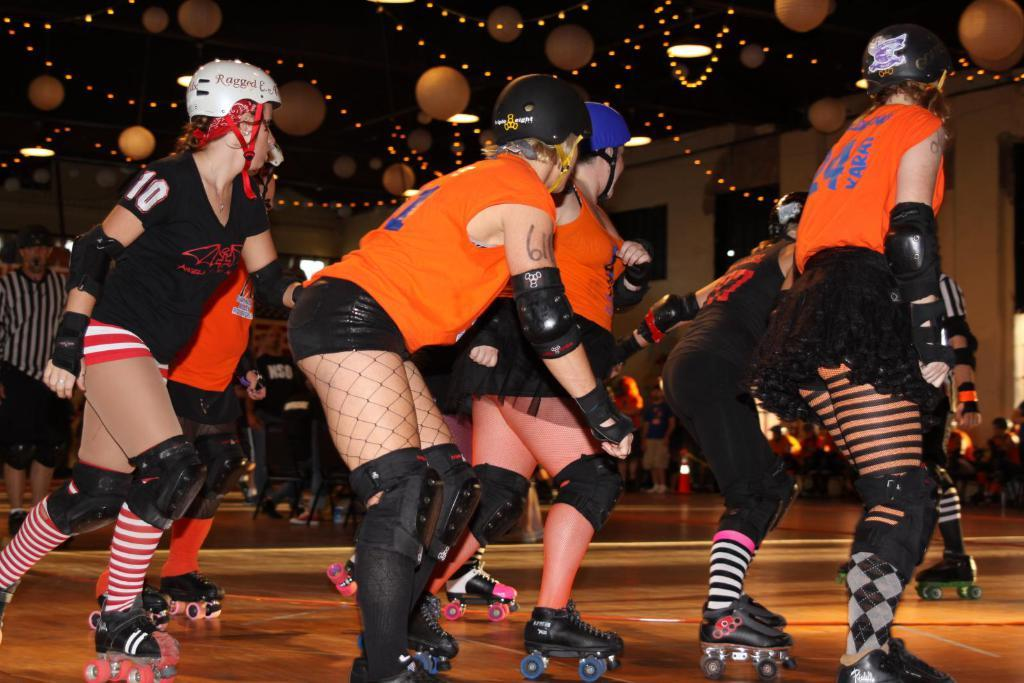Who is present in the image? There are girls in the image. What are the girls doing in the image? The girls are skating on the floor. What can be seen at the top of the image? There are balloons and lights at the top of the image. What type of cream is being used to draw circles on the floor while the girls skate? There is no cream or circles present in the image; the girls are simply skating on the floor. 